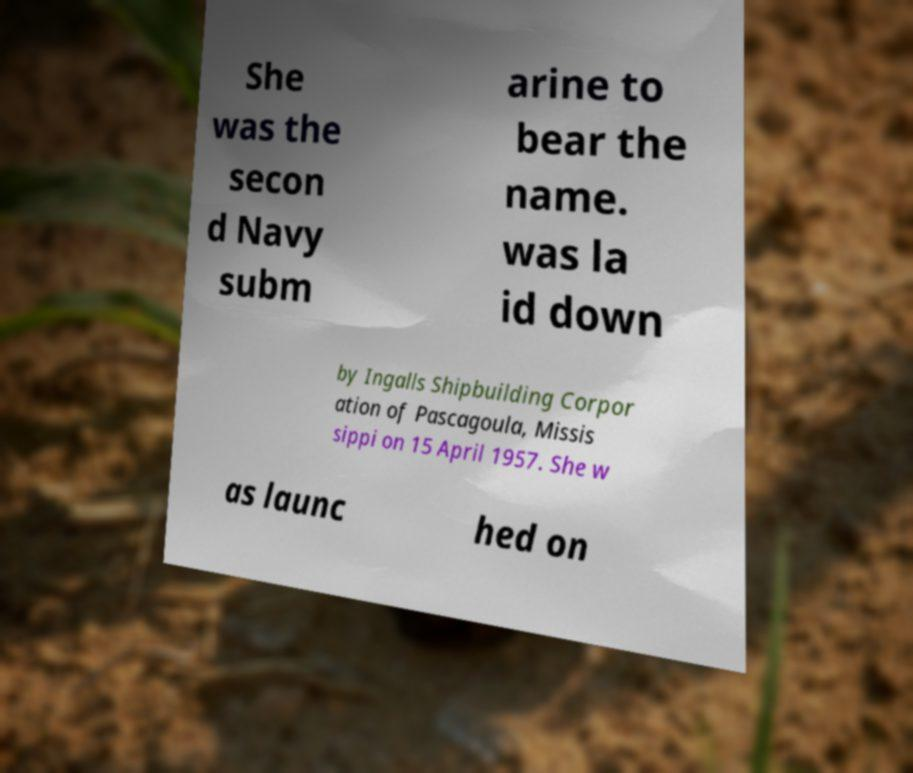Please identify and transcribe the text found in this image. She was the secon d Navy subm arine to bear the name. was la id down by Ingalls Shipbuilding Corpor ation of Pascagoula, Missis sippi on 15 April 1957. She w as launc hed on 